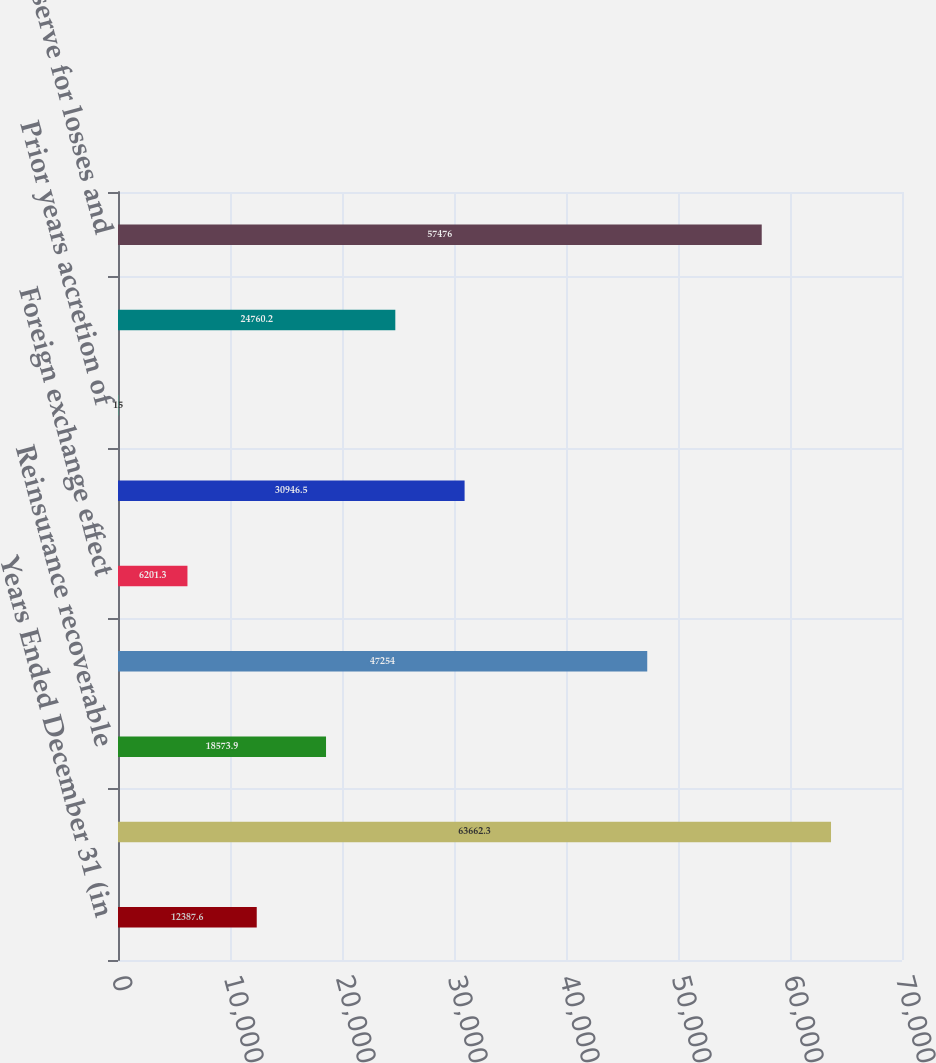Convert chart to OTSL. <chart><loc_0><loc_0><loc_500><loc_500><bar_chart><fcel>Years Ended December 31 (in<fcel>Reserve for losses and loss<fcel>Reinsurance recoverable<fcel>Total<fcel>Foreign exchange effect<fcel>Current year<fcel>Prior years accretion of<fcel>Prior years<fcel>Net reserve for losses and<nl><fcel>12387.6<fcel>63662.3<fcel>18573.9<fcel>47254<fcel>6201.3<fcel>30946.5<fcel>15<fcel>24760.2<fcel>57476<nl></chart> 